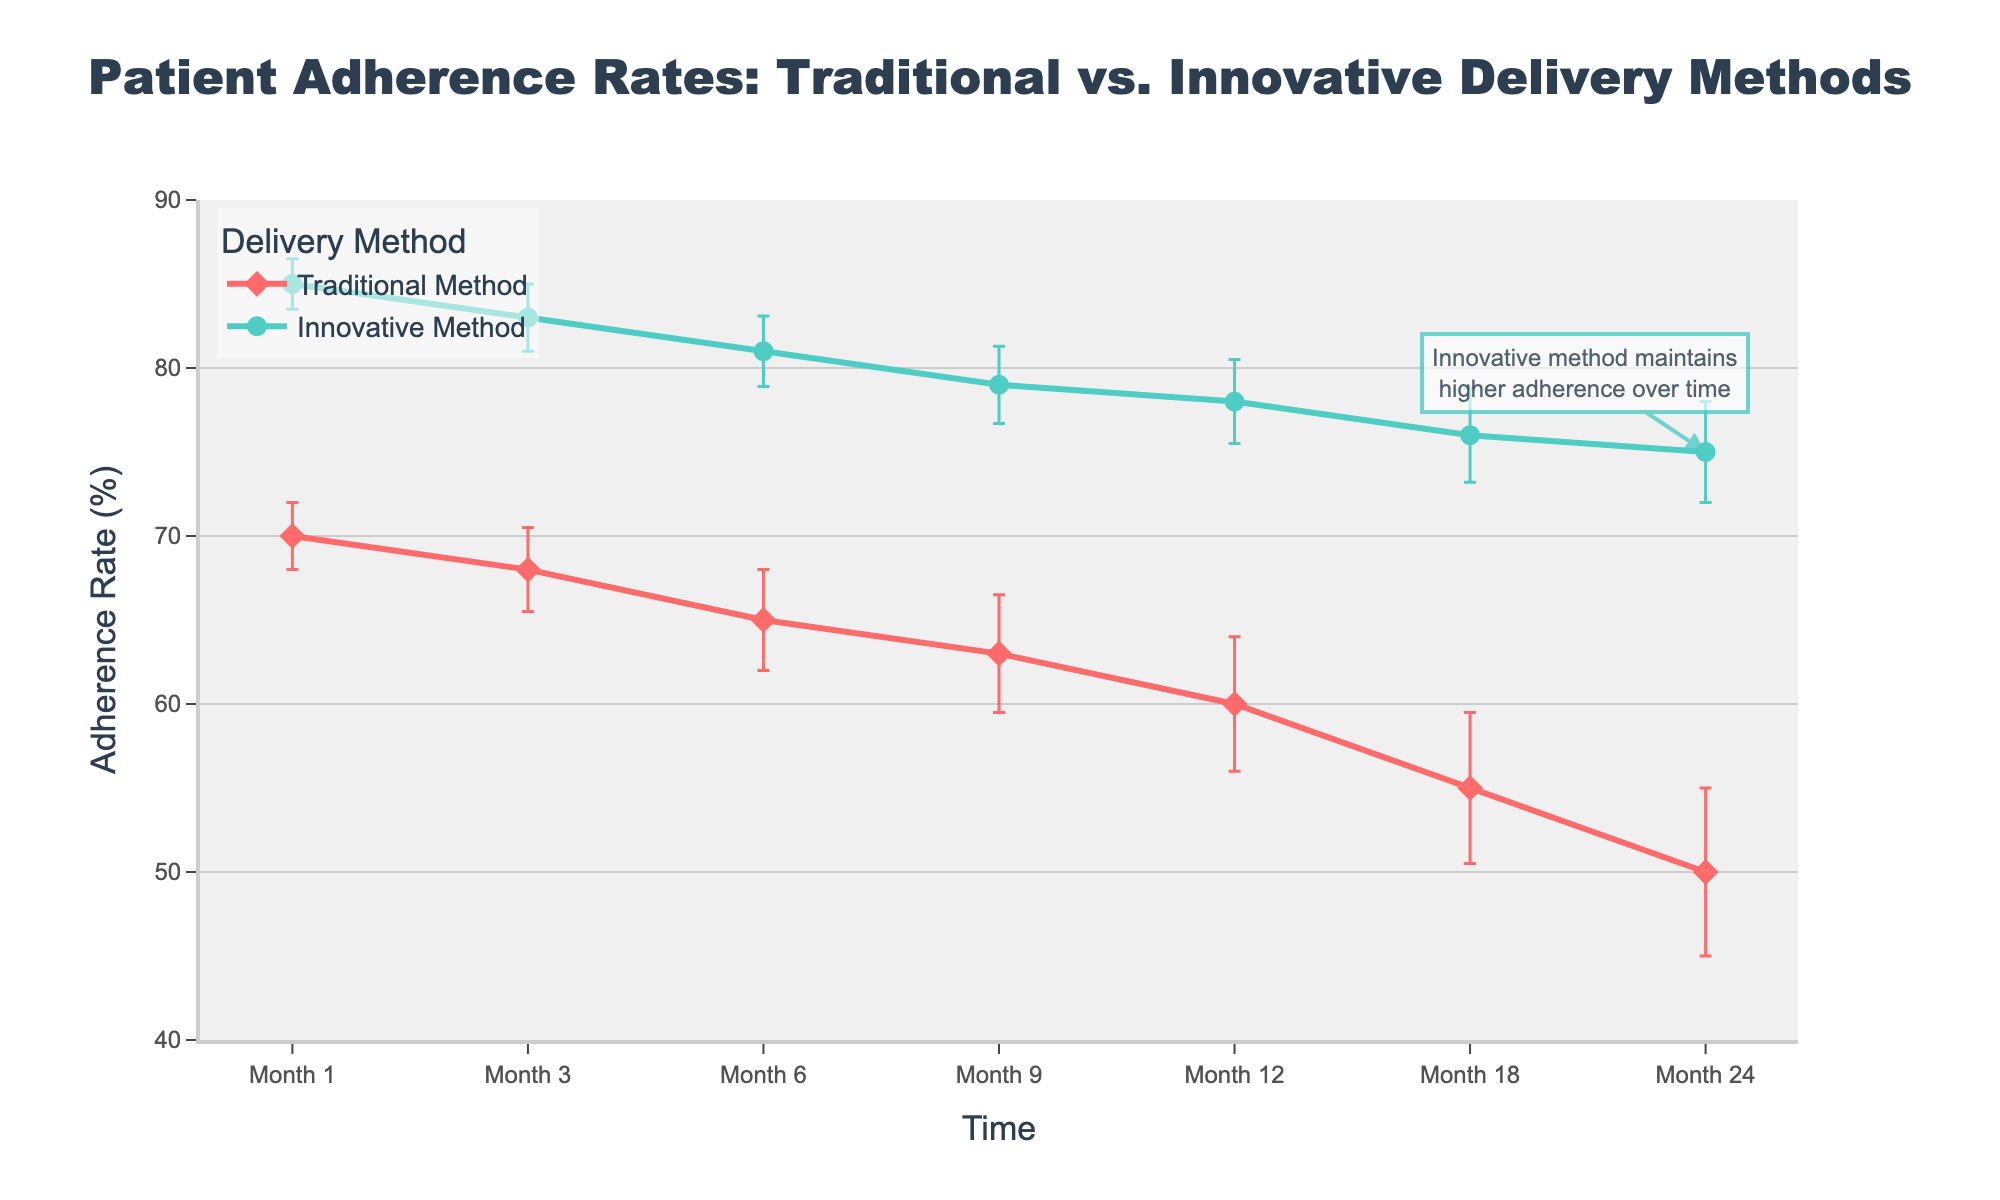What is the title of the plot? The title of the plot is clearly displayed at the top center of the figure in a large, bold font.
Answer: Patient Adherence Rates: Traditional vs. Innovative Delivery Methods How does the adherence rate for the traditional method change from Month 1 to Month 12? The adherence rate for the traditional method decreases steadily over time, from 70% in Month 1 to 60% in Month 12.
Answer: Decreases from 70% to 60% Which delivery method has a higher adherence rate at Month 9? At Month 9, the adherence rate for the innovative method is 79%, and for the traditional method, it is 63%. By comparing these values, we see that the innovative method has a higher adherence rate.
Answer: Innovative method What is the difference in adherence rates between the innovative and traditional methods at Month 24? At Month 24, the innovative method has an adherence rate of 75%, and the traditional method has 50%. The difference is calculated as 75% - 50%.
Answer: 25% What is the range of adherence rates for the traditional method over the entire period? The range is found by subtracting the lowest adherence rate (50% at Month 24) from the highest adherence rate (70% at Month 1).
Answer: 20% Do the error bars for the traditional method overlap with those of the innovative method at Month 18? The adherence rate for the traditional method is 55% with an error of 4.5%, and for the innovative method, it is 76% with an error of 2.8%. The range for traditional is 50.5% to 59.5%, and for innovative is 73.2% to 78.8%. These ranges do not overlap.
Answer: No At which time point is the difference in adherence rates between the two methods the smallest? Throughout the timeline, we need to calculate the differences at each time point: 15%, 15%, 16%, 16%, 18%, 21%, 25%. The smallest difference is 15%, which occurs at Month 1 and Month 3.
Answer: Month 1 and Month 3 How does the standard error for the innovative method change over the observed period? The standard error for the innovative method starts at 1.5% at Month 1 and gradually increases to 3% at Month 24.
Answer: Gradually increases Which method maintains a higher adherence rate throughout the observed period? Observing each time point, it is evident that the innovative method consistently shows higher adherence rates compared to the traditional method.
Answer: Innovative method 